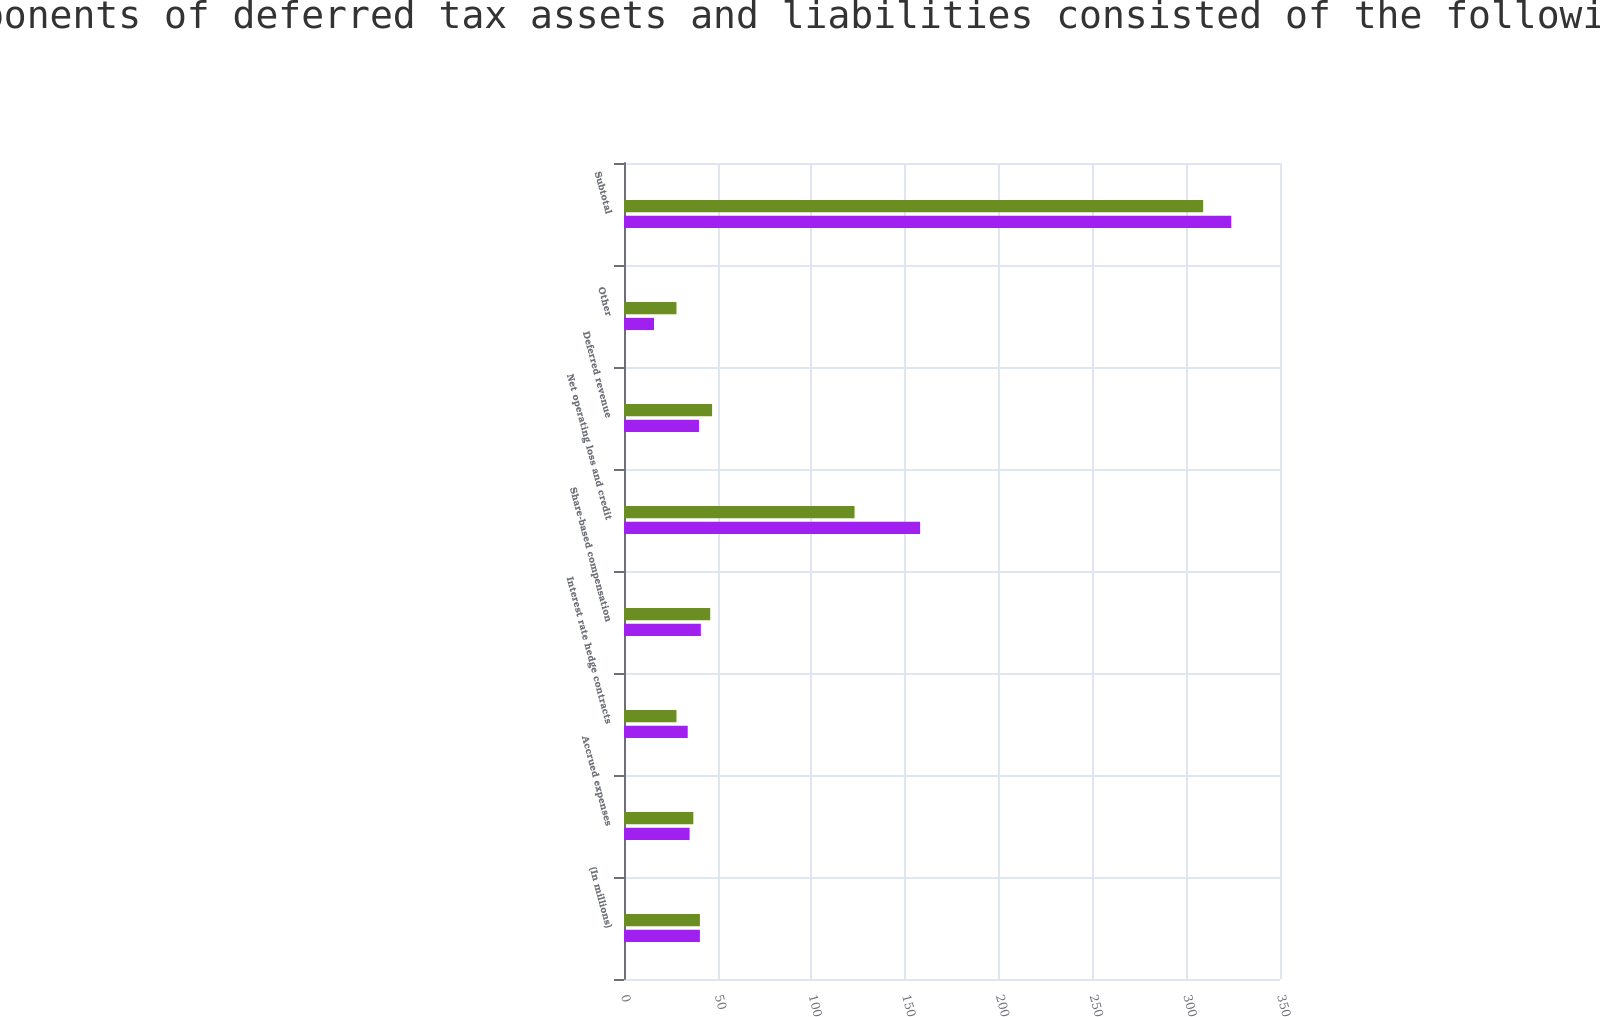Convert chart to OTSL. <chart><loc_0><loc_0><loc_500><loc_500><stacked_bar_chart><ecel><fcel>(In millions)<fcel>Accrued expenses<fcel>Interest rate hedge contracts<fcel>Share-based compensation<fcel>Net operating loss and credit<fcel>Deferred revenue<fcel>Other<fcel>Subtotal<nl><fcel>nan<fcel>40.5<fcel>37<fcel>28<fcel>46<fcel>123<fcel>47<fcel>28<fcel>309<nl><fcel>Significant components of deferred tax assets and liabilities consisted of the following at December 31<fcel>40.5<fcel>35<fcel>34<fcel>41<fcel>158<fcel>40<fcel>16<fcel>324<nl></chart> 